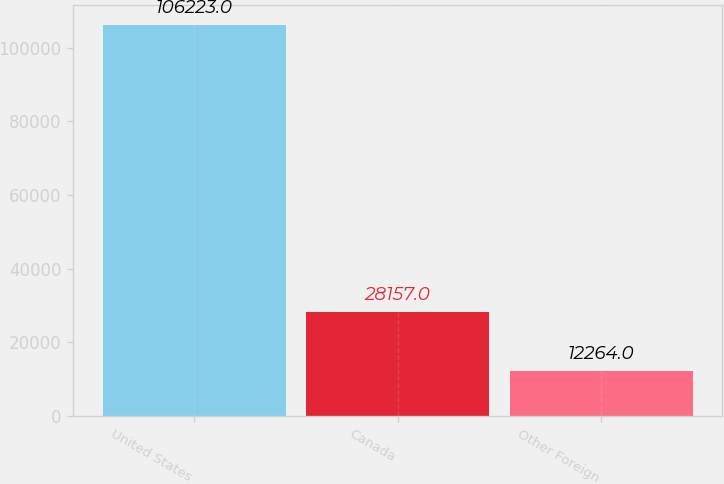Convert chart to OTSL. <chart><loc_0><loc_0><loc_500><loc_500><bar_chart><fcel>United States<fcel>Canada<fcel>Other Foreign<nl><fcel>106223<fcel>28157<fcel>12264<nl></chart> 